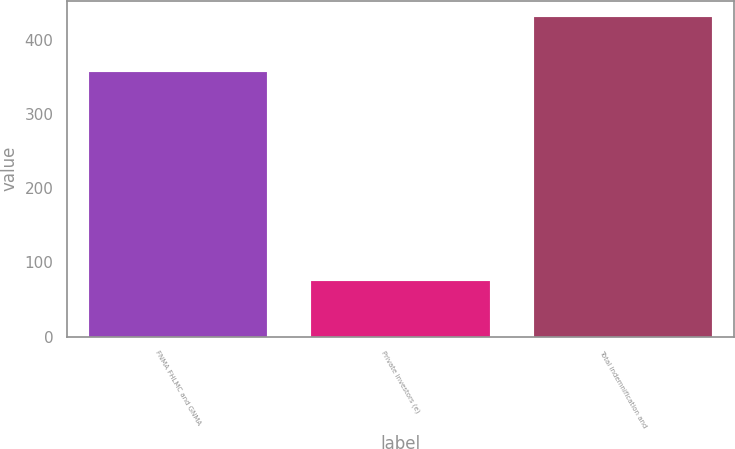<chart> <loc_0><loc_0><loc_500><loc_500><bar_chart><fcel>FNMA FHLMC and GNMA<fcel>Private investors (e)<fcel>Total indemnification and<nl><fcel>356<fcel>75<fcel>431<nl></chart> 